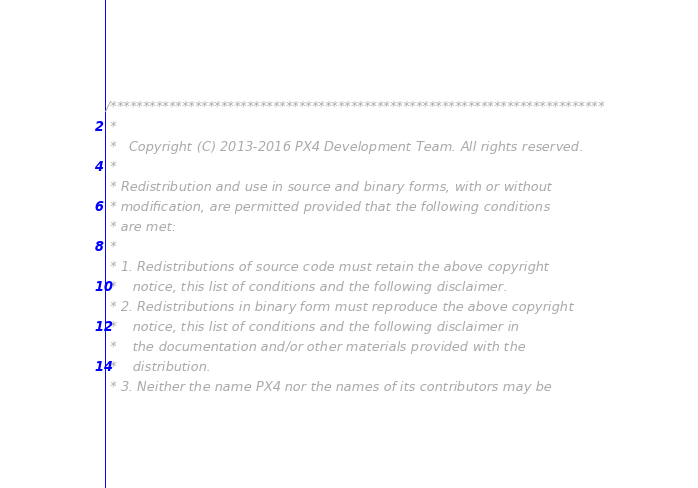<code> <loc_0><loc_0><loc_500><loc_500><_C_>/****************************************************************************
 *
 *   Copyright (C) 2013-2016 PX4 Development Team. All rights reserved.
 *
 * Redistribution and use in source and binary forms, with or without
 * modification, are permitted provided that the following conditions
 * are met:
 *
 * 1. Redistributions of source code must retain the above copyright
 *    notice, this list of conditions and the following disclaimer.
 * 2. Redistributions in binary form must reproduce the above copyright
 *    notice, this list of conditions and the following disclaimer in
 *    the documentation and/or other materials provided with the
 *    distribution.
 * 3. Neither the name PX4 nor the names of its contributors may be</code> 